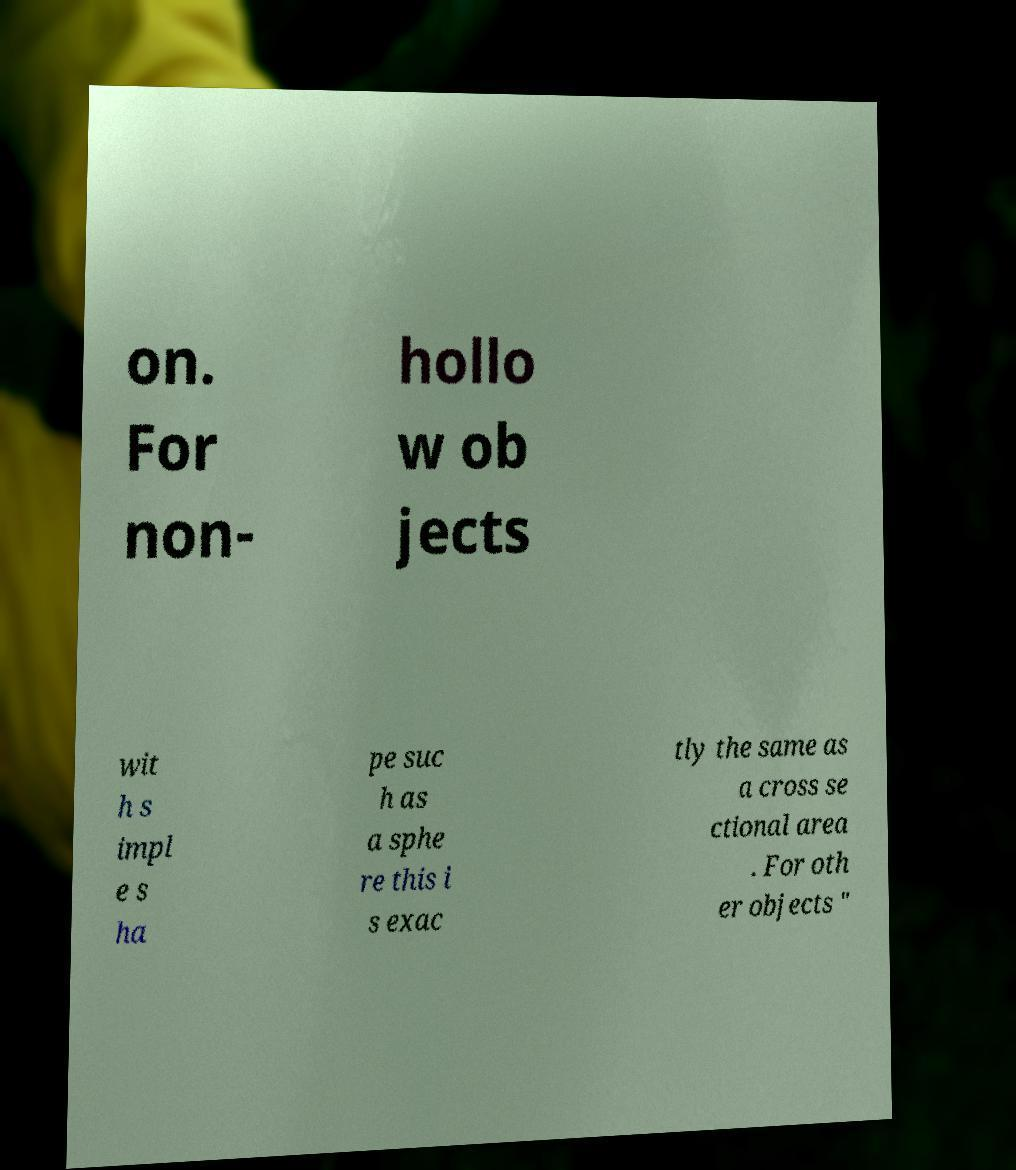For documentation purposes, I need the text within this image transcribed. Could you provide that? on. For non- hollo w ob jects wit h s impl e s ha pe suc h as a sphe re this i s exac tly the same as a cross se ctional area . For oth er objects " 